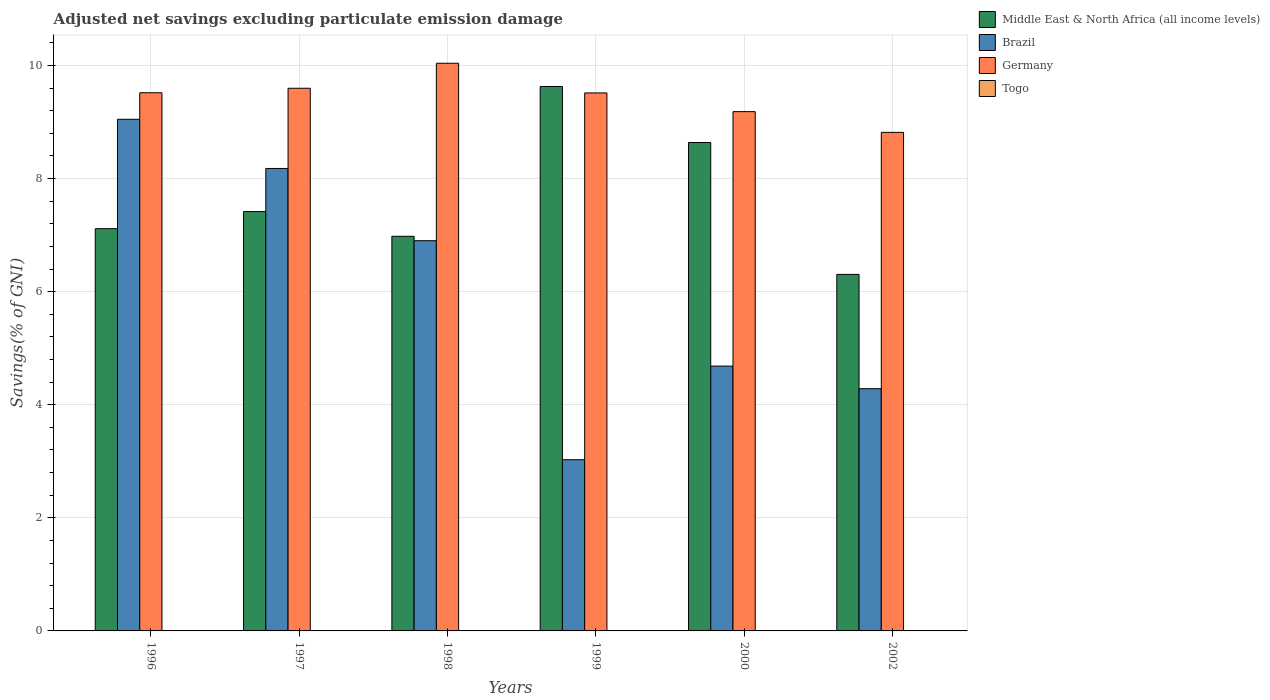How many different coloured bars are there?
Your response must be concise. 3. Are the number of bars per tick equal to the number of legend labels?
Provide a short and direct response. No. How many bars are there on the 3rd tick from the left?
Your response must be concise. 3. What is the label of the 1st group of bars from the left?
Offer a terse response. 1996. In how many cases, is the number of bars for a given year not equal to the number of legend labels?
Offer a very short reply. 6. What is the adjusted net savings in Brazil in 1998?
Give a very brief answer. 6.9. Across all years, what is the maximum adjusted net savings in Germany?
Your answer should be very brief. 10.04. Across all years, what is the minimum adjusted net savings in Middle East & North Africa (all income levels)?
Make the answer very short. 6.31. What is the total adjusted net savings in Brazil in the graph?
Make the answer very short. 36.12. What is the difference between the adjusted net savings in Germany in 2000 and that in 2002?
Provide a short and direct response. 0.37. What is the difference between the adjusted net savings in Germany in 1998 and the adjusted net savings in Togo in 1996?
Provide a short and direct response. 10.04. What is the average adjusted net savings in Germany per year?
Offer a terse response. 9.44. In the year 1998, what is the difference between the adjusted net savings in Middle East & North Africa (all income levels) and adjusted net savings in Brazil?
Offer a terse response. 0.08. What is the ratio of the adjusted net savings in Germany in 1996 to that in 1997?
Offer a very short reply. 0.99. What is the difference between the highest and the second highest adjusted net savings in Brazil?
Offer a very short reply. 0.87. What is the difference between the highest and the lowest adjusted net savings in Germany?
Keep it short and to the point. 1.22. Is it the case that in every year, the sum of the adjusted net savings in Togo and adjusted net savings in Middle East & North Africa (all income levels) is greater than the sum of adjusted net savings in Germany and adjusted net savings in Brazil?
Give a very brief answer. No. Is it the case that in every year, the sum of the adjusted net savings in Brazil and adjusted net savings in Germany is greater than the adjusted net savings in Middle East & North Africa (all income levels)?
Offer a terse response. Yes. How many years are there in the graph?
Make the answer very short. 6. What is the difference between two consecutive major ticks on the Y-axis?
Offer a very short reply. 2. Are the values on the major ticks of Y-axis written in scientific E-notation?
Offer a terse response. No. Does the graph contain any zero values?
Offer a very short reply. Yes. Does the graph contain grids?
Offer a very short reply. Yes. How many legend labels are there?
Your answer should be compact. 4. What is the title of the graph?
Your answer should be compact. Adjusted net savings excluding particulate emission damage. Does "San Marino" appear as one of the legend labels in the graph?
Offer a terse response. No. What is the label or title of the X-axis?
Give a very brief answer. Years. What is the label or title of the Y-axis?
Offer a terse response. Savings(% of GNI). What is the Savings(% of GNI) in Middle East & North Africa (all income levels) in 1996?
Ensure brevity in your answer.  7.11. What is the Savings(% of GNI) in Brazil in 1996?
Offer a very short reply. 9.05. What is the Savings(% of GNI) of Germany in 1996?
Provide a short and direct response. 9.52. What is the Savings(% of GNI) of Togo in 1996?
Your answer should be compact. 0. What is the Savings(% of GNI) of Middle East & North Africa (all income levels) in 1997?
Make the answer very short. 7.42. What is the Savings(% of GNI) of Brazil in 1997?
Provide a short and direct response. 8.18. What is the Savings(% of GNI) in Germany in 1997?
Provide a short and direct response. 9.6. What is the Savings(% of GNI) in Togo in 1997?
Keep it short and to the point. 0. What is the Savings(% of GNI) of Middle East & North Africa (all income levels) in 1998?
Offer a terse response. 6.98. What is the Savings(% of GNI) in Brazil in 1998?
Provide a succinct answer. 6.9. What is the Savings(% of GNI) of Germany in 1998?
Offer a terse response. 10.04. What is the Savings(% of GNI) of Togo in 1998?
Ensure brevity in your answer.  0. What is the Savings(% of GNI) in Middle East & North Africa (all income levels) in 1999?
Ensure brevity in your answer.  9.63. What is the Savings(% of GNI) of Brazil in 1999?
Your response must be concise. 3.03. What is the Savings(% of GNI) in Germany in 1999?
Offer a terse response. 9.51. What is the Savings(% of GNI) of Middle East & North Africa (all income levels) in 2000?
Ensure brevity in your answer.  8.64. What is the Savings(% of GNI) in Brazil in 2000?
Keep it short and to the point. 4.68. What is the Savings(% of GNI) in Germany in 2000?
Ensure brevity in your answer.  9.18. What is the Savings(% of GNI) of Togo in 2000?
Give a very brief answer. 0. What is the Savings(% of GNI) of Middle East & North Africa (all income levels) in 2002?
Your response must be concise. 6.31. What is the Savings(% of GNI) of Brazil in 2002?
Your response must be concise. 4.28. What is the Savings(% of GNI) of Germany in 2002?
Make the answer very short. 8.82. Across all years, what is the maximum Savings(% of GNI) in Middle East & North Africa (all income levels)?
Make the answer very short. 9.63. Across all years, what is the maximum Savings(% of GNI) of Brazil?
Your response must be concise. 9.05. Across all years, what is the maximum Savings(% of GNI) in Germany?
Ensure brevity in your answer.  10.04. Across all years, what is the minimum Savings(% of GNI) of Middle East & North Africa (all income levels)?
Provide a succinct answer. 6.31. Across all years, what is the minimum Savings(% of GNI) in Brazil?
Ensure brevity in your answer.  3.03. Across all years, what is the minimum Savings(% of GNI) of Germany?
Provide a succinct answer. 8.82. What is the total Savings(% of GNI) of Middle East & North Africa (all income levels) in the graph?
Provide a short and direct response. 46.08. What is the total Savings(% of GNI) of Brazil in the graph?
Make the answer very short. 36.12. What is the total Savings(% of GNI) of Germany in the graph?
Keep it short and to the point. 56.67. What is the total Savings(% of GNI) of Togo in the graph?
Give a very brief answer. 0. What is the difference between the Savings(% of GNI) of Middle East & North Africa (all income levels) in 1996 and that in 1997?
Offer a terse response. -0.3. What is the difference between the Savings(% of GNI) in Brazil in 1996 and that in 1997?
Provide a short and direct response. 0.87. What is the difference between the Savings(% of GNI) in Germany in 1996 and that in 1997?
Provide a succinct answer. -0.08. What is the difference between the Savings(% of GNI) of Middle East & North Africa (all income levels) in 1996 and that in 1998?
Your response must be concise. 0.13. What is the difference between the Savings(% of GNI) of Brazil in 1996 and that in 1998?
Give a very brief answer. 2.15. What is the difference between the Savings(% of GNI) in Germany in 1996 and that in 1998?
Offer a very short reply. -0.52. What is the difference between the Savings(% of GNI) of Middle East & North Africa (all income levels) in 1996 and that in 1999?
Offer a terse response. -2.51. What is the difference between the Savings(% of GNI) in Brazil in 1996 and that in 1999?
Your answer should be compact. 6.02. What is the difference between the Savings(% of GNI) in Germany in 1996 and that in 1999?
Your answer should be compact. 0. What is the difference between the Savings(% of GNI) of Middle East & North Africa (all income levels) in 1996 and that in 2000?
Your answer should be very brief. -1.52. What is the difference between the Savings(% of GNI) in Brazil in 1996 and that in 2000?
Your answer should be compact. 4.36. What is the difference between the Savings(% of GNI) in Germany in 1996 and that in 2000?
Keep it short and to the point. 0.33. What is the difference between the Savings(% of GNI) in Middle East & North Africa (all income levels) in 1996 and that in 2002?
Keep it short and to the point. 0.81. What is the difference between the Savings(% of GNI) of Brazil in 1996 and that in 2002?
Provide a succinct answer. 4.76. What is the difference between the Savings(% of GNI) in Germany in 1996 and that in 2002?
Make the answer very short. 0.7. What is the difference between the Savings(% of GNI) in Middle East & North Africa (all income levels) in 1997 and that in 1998?
Provide a short and direct response. 0.44. What is the difference between the Savings(% of GNI) in Brazil in 1997 and that in 1998?
Your answer should be compact. 1.28. What is the difference between the Savings(% of GNI) of Germany in 1997 and that in 1998?
Offer a terse response. -0.44. What is the difference between the Savings(% of GNI) in Middle East & North Africa (all income levels) in 1997 and that in 1999?
Provide a short and direct response. -2.21. What is the difference between the Savings(% of GNI) in Brazil in 1997 and that in 1999?
Provide a short and direct response. 5.15. What is the difference between the Savings(% of GNI) in Germany in 1997 and that in 1999?
Offer a very short reply. 0.08. What is the difference between the Savings(% of GNI) in Middle East & North Africa (all income levels) in 1997 and that in 2000?
Provide a short and direct response. -1.22. What is the difference between the Savings(% of GNI) in Brazil in 1997 and that in 2000?
Your answer should be very brief. 3.49. What is the difference between the Savings(% of GNI) of Germany in 1997 and that in 2000?
Give a very brief answer. 0.41. What is the difference between the Savings(% of GNI) of Middle East & North Africa (all income levels) in 1997 and that in 2002?
Your answer should be very brief. 1.11. What is the difference between the Savings(% of GNI) in Brazil in 1997 and that in 2002?
Your answer should be compact. 3.89. What is the difference between the Savings(% of GNI) in Germany in 1997 and that in 2002?
Offer a very short reply. 0.78. What is the difference between the Savings(% of GNI) of Middle East & North Africa (all income levels) in 1998 and that in 1999?
Make the answer very short. -2.65. What is the difference between the Savings(% of GNI) of Brazil in 1998 and that in 1999?
Your answer should be compact. 3.87. What is the difference between the Savings(% of GNI) of Germany in 1998 and that in 1999?
Give a very brief answer. 0.52. What is the difference between the Savings(% of GNI) of Middle East & North Africa (all income levels) in 1998 and that in 2000?
Provide a succinct answer. -1.66. What is the difference between the Savings(% of GNI) of Brazil in 1998 and that in 2000?
Your answer should be compact. 2.22. What is the difference between the Savings(% of GNI) in Germany in 1998 and that in 2000?
Provide a succinct answer. 0.86. What is the difference between the Savings(% of GNI) of Middle East & North Africa (all income levels) in 1998 and that in 2002?
Ensure brevity in your answer.  0.67. What is the difference between the Savings(% of GNI) of Brazil in 1998 and that in 2002?
Provide a succinct answer. 2.62. What is the difference between the Savings(% of GNI) of Germany in 1998 and that in 2002?
Offer a terse response. 1.22. What is the difference between the Savings(% of GNI) in Middle East & North Africa (all income levels) in 1999 and that in 2000?
Offer a terse response. 0.99. What is the difference between the Savings(% of GNI) of Brazil in 1999 and that in 2000?
Offer a very short reply. -1.66. What is the difference between the Savings(% of GNI) in Germany in 1999 and that in 2000?
Provide a short and direct response. 0.33. What is the difference between the Savings(% of GNI) of Middle East & North Africa (all income levels) in 1999 and that in 2002?
Give a very brief answer. 3.32. What is the difference between the Savings(% of GNI) in Brazil in 1999 and that in 2002?
Offer a terse response. -1.26. What is the difference between the Savings(% of GNI) in Germany in 1999 and that in 2002?
Provide a succinct answer. 0.7. What is the difference between the Savings(% of GNI) in Middle East & North Africa (all income levels) in 2000 and that in 2002?
Provide a short and direct response. 2.33. What is the difference between the Savings(% of GNI) of Brazil in 2000 and that in 2002?
Provide a succinct answer. 0.4. What is the difference between the Savings(% of GNI) in Germany in 2000 and that in 2002?
Ensure brevity in your answer.  0.37. What is the difference between the Savings(% of GNI) in Middle East & North Africa (all income levels) in 1996 and the Savings(% of GNI) in Brazil in 1997?
Provide a short and direct response. -1.06. What is the difference between the Savings(% of GNI) in Middle East & North Africa (all income levels) in 1996 and the Savings(% of GNI) in Germany in 1997?
Make the answer very short. -2.48. What is the difference between the Savings(% of GNI) in Brazil in 1996 and the Savings(% of GNI) in Germany in 1997?
Offer a very short reply. -0.55. What is the difference between the Savings(% of GNI) in Middle East & North Africa (all income levels) in 1996 and the Savings(% of GNI) in Brazil in 1998?
Your answer should be very brief. 0.21. What is the difference between the Savings(% of GNI) of Middle East & North Africa (all income levels) in 1996 and the Savings(% of GNI) of Germany in 1998?
Your answer should be very brief. -2.93. What is the difference between the Savings(% of GNI) of Brazil in 1996 and the Savings(% of GNI) of Germany in 1998?
Provide a short and direct response. -0.99. What is the difference between the Savings(% of GNI) in Middle East & North Africa (all income levels) in 1996 and the Savings(% of GNI) in Brazil in 1999?
Your answer should be very brief. 4.09. What is the difference between the Savings(% of GNI) in Middle East & North Africa (all income levels) in 1996 and the Savings(% of GNI) in Germany in 1999?
Provide a succinct answer. -2.4. What is the difference between the Savings(% of GNI) of Brazil in 1996 and the Savings(% of GNI) of Germany in 1999?
Your response must be concise. -0.47. What is the difference between the Savings(% of GNI) in Middle East & North Africa (all income levels) in 1996 and the Savings(% of GNI) in Brazil in 2000?
Keep it short and to the point. 2.43. What is the difference between the Savings(% of GNI) in Middle East & North Africa (all income levels) in 1996 and the Savings(% of GNI) in Germany in 2000?
Offer a terse response. -2.07. What is the difference between the Savings(% of GNI) in Brazil in 1996 and the Savings(% of GNI) in Germany in 2000?
Provide a short and direct response. -0.14. What is the difference between the Savings(% of GNI) of Middle East & North Africa (all income levels) in 1996 and the Savings(% of GNI) of Brazil in 2002?
Make the answer very short. 2.83. What is the difference between the Savings(% of GNI) of Middle East & North Africa (all income levels) in 1996 and the Savings(% of GNI) of Germany in 2002?
Give a very brief answer. -1.7. What is the difference between the Savings(% of GNI) of Brazil in 1996 and the Savings(% of GNI) of Germany in 2002?
Provide a short and direct response. 0.23. What is the difference between the Savings(% of GNI) in Middle East & North Africa (all income levels) in 1997 and the Savings(% of GNI) in Brazil in 1998?
Your answer should be very brief. 0.51. What is the difference between the Savings(% of GNI) in Middle East & North Africa (all income levels) in 1997 and the Savings(% of GNI) in Germany in 1998?
Your answer should be very brief. -2.62. What is the difference between the Savings(% of GNI) of Brazil in 1997 and the Savings(% of GNI) of Germany in 1998?
Your response must be concise. -1.86. What is the difference between the Savings(% of GNI) in Middle East & North Africa (all income levels) in 1997 and the Savings(% of GNI) in Brazil in 1999?
Provide a succinct answer. 4.39. What is the difference between the Savings(% of GNI) of Middle East & North Africa (all income levels) in 1997 and the Savings(% of GNI) of Germany in 1999?
Provide a short and direct response. -2.1. What is the difference between the Savings(% of GNI) in Brazil in 1997 and the Savings(% of GNI) in Germany in 1999?
Give a very brief answer. -1.34. What is the difference between the Savings(% of GNI) in Middle East & North Africa (all income levels) in 1997 and the Savings(% of GNI) in Brazil in 2000?
Ensure brevity in your answer.  2.73. What is the difference between the Savings(% of GNI) in Middle East & North Africa (all income levels) in 1997 and the Savings(% of GNI) in Germany in 2000?
Give a very brief answer. -1.77. What is the difference between the Savings(% of GNI) of Brazil in 1997 and the Savings(% of GNI) of Germany in 2000?
Give a very brief answer. -1. What is the difference between the Savings(% of GNI) of Middle East & North Africa (all income levels) in 1997 and the Savings(% of GNI) of Brazil in 2002?
Give a very brief answer. 3.13. What is the difference between the Savings(% of GNI) in Middle East & North Africa (all income levels) in 1997 and the Savings(% of GNI) in Germany in 2002?
Provide a short and direct response. -1.4. What is the difference between the Savings(% of GNI) of Brazil in 1997 and the Savings(% of GNI) of Germany in 2002?
Your answer should be very brief. -0.64. What is the difference between the Savings(% of GNI) in Middle East & North Africa (all income levels) in 1998 and the Savings(% of GNI) in Brazil in 1999?
Your response must be concise. 3.95. What is the difference between the Savings(% of GNI) of Middle East & North Africa (all income levels) in 1998 and the Savings(% of GNI) of Germany in 1999?
Your answer should be compact. -2.54. What is the difference between the Savings(% of GNI) of Brazil in 1998 and the Savings(% of GNI) of Germany in 1999?
Provide a succinct answer. -2.61. What is the difference between the Savings(% of GNI) of Middle East & North Africa (all income levels) in 1998 and the Savings(% of GNI) of Brazil in 2000?
Offer a terse response. 2.3. What is the difference between the Savings(% of GNI) in Middle East & North Africa (all income levels) in 1998 and the Savings(% of GNI) in Germany in 2000?
Make the answer very short. -2.2. What is the difference between the Savings(% of GNI) of Brazil in 1998 and the Savings(% of GNI) of Germany in 2000?
Offer a very short reply. -2.28. What is the difference between the Savings(% of GNI) in Middle East & North Africa (all income levels) in 1998 and the Savings(% of GNI) in Brazil in 2002?
Your answer should be very brief. 2.7. What is the difference between the Savings(% of GNI) of Middle East & North Africa (all income levels) in 1998 and the Savings(% of GNI) of Germany in 2002?
Ensure brevity in your answer.  -1.84. What is the difference between the Savings(% of GNI) of Brazil in 1998 and the Savings(% of GNI) of Germany in 2002?
Keep it short and to the point. -1.92. What is the difference between the Savings(% of GNI) of Middle East & North Africa (all income levels) in 1999 and the Savings(% of GNI) of Brazil in 2000?
Offer a very short reply. 4.94. What is the difference between the Savings(% of GNI) in Middle East & North Africa (all income levels) in 1999 and the Savings(% of GNI) in Germany in 2000?
Offer a very short reply. 0.44. What is the difference between the Savings(% of GNI) in Brazil in 1999 and the Savings(% of GNI) in Germany in 2000?
Provide a succinct answer. -6.16. What is the difference between the Savings(% of GNI) in Middle East & North Africa (all income levels) in 1999 and the Savings(% of GNI) in Brazil in 2002?
Your response must be concise. 5.34. What is the difference between the Savings(% of GNI) in Middle East & North Africa (all income levels) in 1999 and the Savings(% of GNI) in Germany in 2002?
Your response must be concise. 0.81. What is the difference between the Savings(% of GNI) in Brazil in 1999 and the Savings(% of GNI) in Germany in 2002?
Your answer should be very brief. -5.79. What is the difference between the Savings(% of GNI) of Middle East & North Africa (all income levels) in 2000 and the Savings(% of GNI) of Brazil in 2002?
Provide a short and direct response. 4.35. What is the difference between the Savings(% of GNI) in Middle East & North Africa (all income levels) in 2000 and the Savings(% of GNI) in Germany in 2002?
Keep it short and to the point. -0.18. What is the difference between the Savings(% of GNI) in Brazil in 2000 and the Savings(% of GNI) in Germany in 2002?
Ensure brevity in your answer.  -4.13. What is the average Savings(% of GNI) of Middle East & North Africa (all income levels) per year?
Keep it short and to the point. 7.68. What is the average Savings(% of GNI) in Brazil per year?
Make the answer very short. 6.02. What is the average Savings(% of GNI) in Germany per year?
Provide a succinct answer. 9.44. What is the average Savings(% of GNI) in Togo per year?
Your response must be concise. 0. In the year 1996, what is the difference between the Savings(% of GNI) in Middle East & North Africa (all income levels) and Savings(% of GNI) in Brazil?
Your answer should be very brief. -1.93. In the year 1996, what is the difference between the Savings(% of GNI) in Middle East & North Africa (all income levels) and Savings(% of GNI) in Germany?
Give a very brief answer. -2.4. In the year 1996, what is the difference between the Savings(% of GNI) of Brazil and Savings(% of GNI) of Germany?
Ensure brevity in your answer.  -0.47. In the year 1997, what is the difference between the Savings(% of GNI) of Middle East & North Africa (all income levels) and Savings(% of GNI) of Brazil?
Offer a very short reply. -0.76. In the year 1997, what is the difference between the Savings(% of GNI) of Middle East & North Africa (all income levels) and Savings(% of GNI) of Germany?
Keep it short and to the point. -2.18. In the year 1997, what is the difference between the Savings(% of GNI) of Brazil and Savings(% of GNI) of Germany?
Keep it short and to the point. -1.42. In the year 1998, what is the difference between the Savings(% of GNI) in Middle East & North Africa (all income levels) and Savings(% of GNI) in Brazil?
Keep it short and to the point. 0.08. In the year 1998, what is the difference between the Savings(% of GNI) of Middle East & North Africa (all income levels) and Savings(% of GNI) of Germany?
Your answer should be very brief. -3.06. In the year 1998, what is the difference between the Savings(% of GNI) of Brazil and Savings(% of GNI) of Germany?
Keep it short and to the point. -3.14. In the year 1999, what is the difference between the Savings(% of GNI) of Middle East & North Africa (all income levels) and Savings(% of GNI) of Brazil?
Keep it short and to the point. 6.6. In the year 1999, what is the difference between the Savings(% of GNI) of Middle East & North Africa (all income levels) and Savings(% of GNI) of Germany?
Provide a succinct answer. 0.11. In the year 1999, what is the difference between the Savings(% of GNI) of Brazil and Savings(% of GNI) of Germany?
Offer a terse response. -6.49. In the year 2000, what is the difference between the Savings(% of GNI) in Middle East & North Africa (all income levels) and Savings(% of GNI) in Brazil?
Provide a short and direct response. 3.95. In the year 2000, what is the difference between the Savings(% of GNI) in Middle East & North Africa (all income levels) and Savings(% of GNI) in Germany?
Your response must be concise. -0.55. In the year 2000, what is the difference between the Savings(% of GNI) in Brazil and Savings(% of GNI) in Germany?
Make the answer very short. -4.5. In the year 2002, what is the difference between the Savings(% of GNI) of Middle East & North Africa (all income levels) and Savings(% of GNI) of Brazil?
Make the answer very short. 2.02. In the year 2002, what is the difference between the Savings(% of GNI) in Middle East & North Africa (all income levels) and Savings(% of GNI) in Germany?
Give a very brief answer. -2.51. In the year 2002, what is the difference between the Savings(% of GNI) in Brazil and Savings(% of GNI) in Germany?
Provide a short and direct response. -4.53. What is the ratio of the Savings(% of GNI) in Middle East & North Africa (all income levels) in 1996 to that in 1997?
Ensure brevity in your answer.  0.96. What is the ratio of the Savings(% of GNI) of Brazil in 1996 to that in 1997?
Offer a very short reply. 1.11. What is the ratio of the Savings(% of GNI) of Germany in 1996 to that in 1997?
Your answer should be very brief. 0.99. What is the ratio of the Savings(% of GNI) of Middle East & North Africa (all income levels) in 1996 to that in 1998?
Make the answer very short. 1.02. What is the ratio of the Savings(% of GNI) in Brazil in 1996 to that in 1998?
Make the answer very short. 1.31. What is the ratio of the Savings(% of GNI) in Germany in 1996 to that in 1998?
Provide a succinct answer. 0.95. What is the ratio of the Savings(% of GNI) of Middle East & North Africa (all income levels) in 1996 to that in 1999?
Offer a very short reply. 0.74. What is the ratio of the Savings(% of GNI) in Brazil in 1996 to that in 1999?
Offer a terse response. 2.99. What is the ratio of the Savings(% of GNI) of Middle East & North Africa (all income levels) in 1996 to that in 2000?
Provide a short and direct response. 0.82. What is the ratio of the Savings(% of GNI) in Brazil in 1996 to that in 2000?
Your response must be concise. 1.93. What is the ratio of the Savings(% of GNI) in Germany in 1996 to that in 2000?
Ensure brevity in your answer.  1.04. What is the ratio of the Savings(% of GNI) in Middle East & North Africa (all income levels) in 1996 to that in 2002?
Give a very brief answer. 1.13. What is the ratio of the Savings(% of GNI) of Brazil in 1996 to that in 2002?
Offer a very short reply. 2.11. What is the ratio of the Savings(% of GNI) of Germany in 1996 to that in 2002?
Your response must be concise. 1.08. What is the ratio of the Savings(% of GNI) of Middle East & North Africa (all income levels) in 1997 to that in 1998?
Ensure brevity in your answer.  1.06. What is the ratio of the Savings(% of GNI) of Brazil in 1997 to that in 1998?
Ensure brevity in your answer.  1.19. What is the ratio of the Savings(% of GNI) in Germany in 1997 to that in 1998?
Give a very brief answer. 0.96. What is the ratio of the Savings(% of GNI) in Middle East & North Africa (all income levels) in 1997 to that in 1999?
Provide a short and direct response. 0.77. What is the ratio of the Savings(% of GNI) of Brazil in 1997 to that in 1999?
Offer a terse response. 2.7. What is the ratio of the Savings(% of GNI) in Germany in 1997 to that in 1999?
Provide a succinct answer. 1.01. What is the ratio of the Savings(% of GNI) in Middle East & North Africa (all income levels) in 1997 to that in 2000?
Keep it short and to the point. 0.86. What is the ratio of the Savings(% of GNI) of Brazil in 1997 to that in 2000?
Your answer should be very brief. 1.75. What is the ratio of the Savings(% of GNI) of Germany in 1997 to that in 2000?
Give a very brief answer. 1.04. What is the ratio of the Savings(% of GNI) in Middle East & North Africa (all income levels) in 1997 to that in 2002?
Your response must be concise. 1.18. What is the ratio of the Savings(% of GNI) in Brazil in 1997 to that in 2002?
Your answer should be very brief. 1.91. What is the ratio of the Savings(% of GNI) in Germany in 1997 to that in 2002?
Offer a terse response. 1.09. What is the ratio of the Savings(% of GNI) in Middle East & North Africa (all income levels) in 1998 to that in 1999?
Ensure brevity in your answer.  0.72. What is the ratio of the Savings(% of GNI) of Brazil in 1998 to that in 1999?
Provide a short and direct response. 2.28. What is the ratio of the Savings(% of GNI) of Germany in 1998 to that in 1999?
Your answer should be compact. 1.06. What is the ratio of the Savings(% of GNI) of Middle East & North Africa (all income levels) in 1998 to that in 2000?
Offer a very short reply. 0.81. What is the ratio of the Savings(% of GNI) in Brazil in 1998 to that in 2000?
Offer a terse response. 1.47. What is the ratio of the Savings(% of GNI) in Germany in 1998 to that in 2000?
Offer a terse response. 1.09. What is the ratio of the Savings(% of GNI) in Middle East & North Africa (all income levels) in 1998 to that in 2002?
Your response must be concise. 1.11. What is the ratio of the Savings(% of GNI) in Brazil in 1998 to that in 2002?
Offer a terse response. 1.61. What is the ratio of the Savings(% of GNI) in Germany in 1998 to that in 2002?
Make the answer very short. 1.14. What is the ratio of the Savings(% of GNI) of Middle East & North Africa (all income levels) in 1999 to that in 2000?
Your response must be concise. 1.11. What is the ratio of the Savings(% of GNI) of Brazil in 1999 to that in 2000?
Give a very brief answer. 0.65. What is the ratio of the Savings(% of GNI) in Germany in 1999 to that in 2000?
Your answer should be compact. 1.04. What is the ratio of the Savings(% of GNI) in Middle East & North Africa (all income levels) in 1999 to that in 2002?
Offer a terse response. 1.53. What is the ratio of the Savings(% of GNI) of Brazil in 1999 to that in 2002?
Provide a succinct answer. 0.71. What is the ratio of the Savings(% of GNI) of Germany in 1999 to that in 2002?
Give a very brief answer. 1.08. What is the ratio of the Savings(% of GNI) of Middle East & North Africa (all income levels) in 2000 to that in 2002?
Keep it short and to the point. 1.37. What is the ratio of the Savings(% of GNI) in Brazil in 2000 to that in 2002?
Provide a succinct answer. 1.09. What is the ratio of the Savings(% of GNI) in Germany in 2000 to that in 2002?
Provide a succinct answer. 1.04. What is the difference between the highest and the second highest Savings(% of GNI) in Middle East & North Africa (all income levels)?
Offer a very short reply. 0.99. What is the difference between the highest and the second highest Savings(% of GNI) of Brazil?
Your answer should be compact. 0.87. What is the difference between the highest and the second highest Savings(% of GNI) in Germany?
Keep it short and to the point. 0.44. What is the difference between the highest and the lowest Savings(% of GNI) in Middle East & North Africa (all income levels)?
Offer a terse response. 3.32. What is the difference between the highest and the lowest Savings(% of GNI) of Brazil?
Keep it short and to the point. 6.02. What is the difference between the highest and the lowest Savings(% of GNI) in Germany?
Provide a short and direct response. 1.22. 